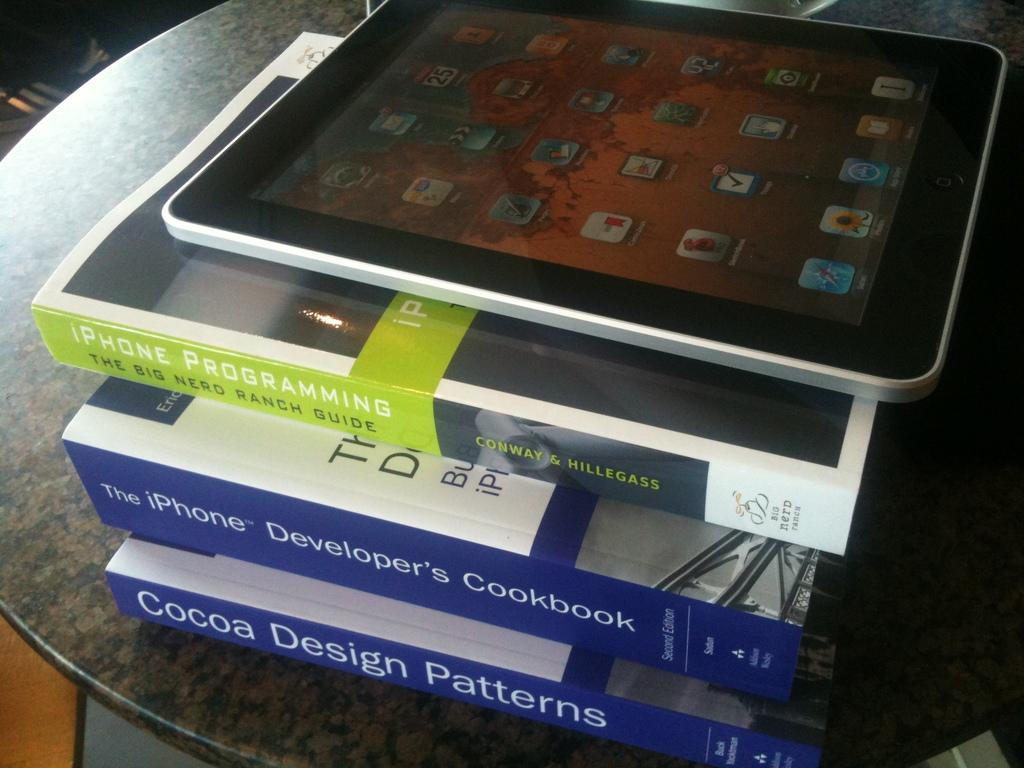How many books are visible in the image? There are three books in the image. Where are the books located? The books are on a surface. What can be seen on top of the books? There is a tab on top of the books. What type of marble is visible on the books in the image? There is no marble present on the books in the image. How many tickets are placed on top of the books in the image? There are no tickets present on top of the books in the image. 